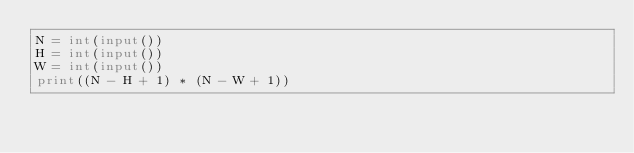Convert code to text. <code><loc_0><loc_0><loc_500><loc_500><_Python_>N = int(input())
H = int(input())
W = int(input())
print((N - H + 1) * (N - W + 1))</code> 